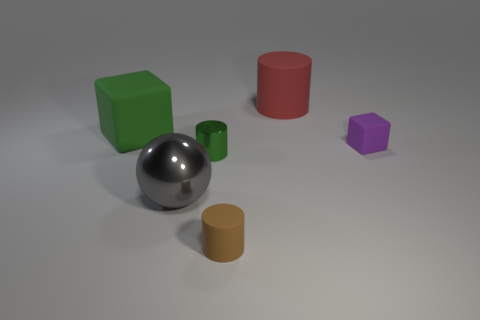What material is the green thing that is the same shape as the brown rubber thing?
Your response must be concise. Metal. There is a matte object that is to the left of the green shiny cylinder; does it have the same color as the small object left of the brown matte cylinder?
Offer a terse response. Yes. Is there a green matte thing that has the same size as the shiny cylinder?
Provide a succinct answer. No. There is a big object that is to the right of the large green cube and in front of the red thing; what is its material?
Provide a succinct answer. Metal. How many shiny objects are either tiny brown cylinders or small red spheres?
Make the answer very short. 0. What is the shape of the green object that is the same material as the gray sphere?
Your answer should be very brief. Cylinder. What number of matte objects are behind the small metallic cylinder and in front of the large cylinder?
Ensure brevity in your answer.  2. Is there anything else that is the same shape as the large gray thing?
Provide a succinct answer. No. There is a thing that is behind the large rubber block; how big is it?
Offer a terse response. Large. How many other things are there of the same color as the tiny metal cylinder?
Your answer should be very brief. 1. 